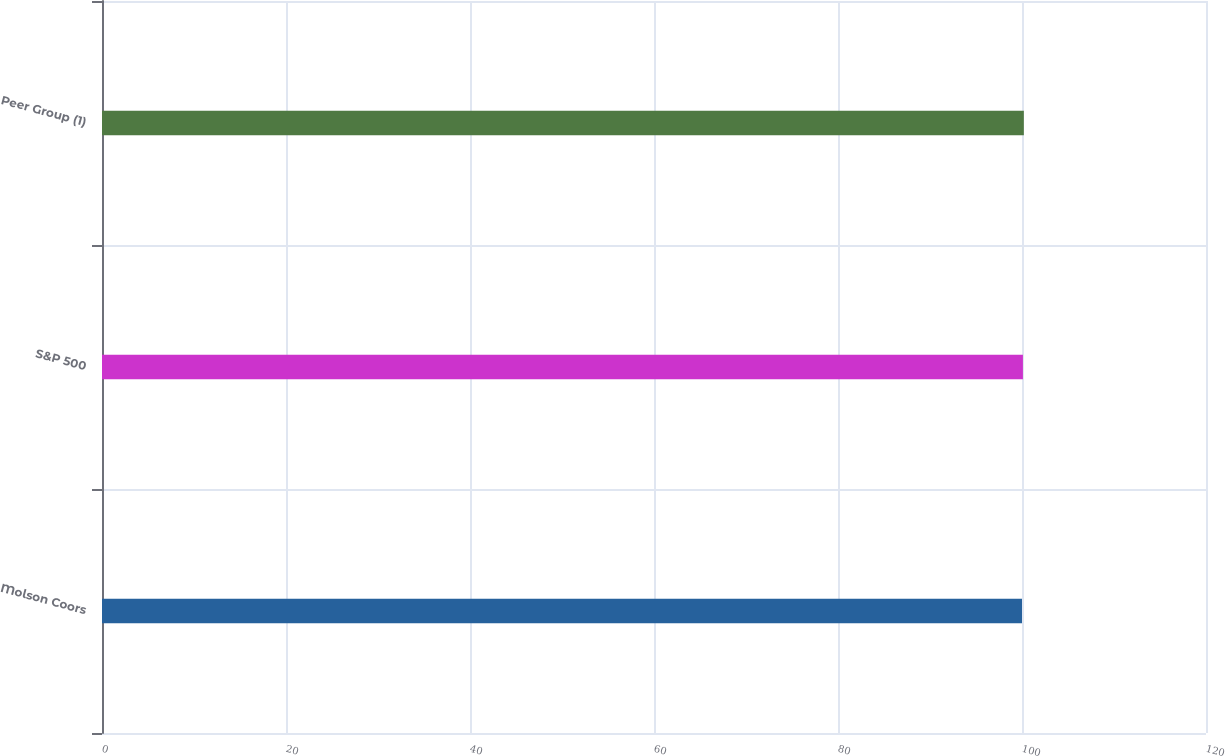Convert chart to OTSL. <chart><loc_0><loc_0><loc_500><loc_500><bar_chart><fcel>Molson Coors<fcel>S&P 500<fcel>Peer Group (1)<nl><fcel>100<fcel>100.1<fcel>100.2<nl></chart> 